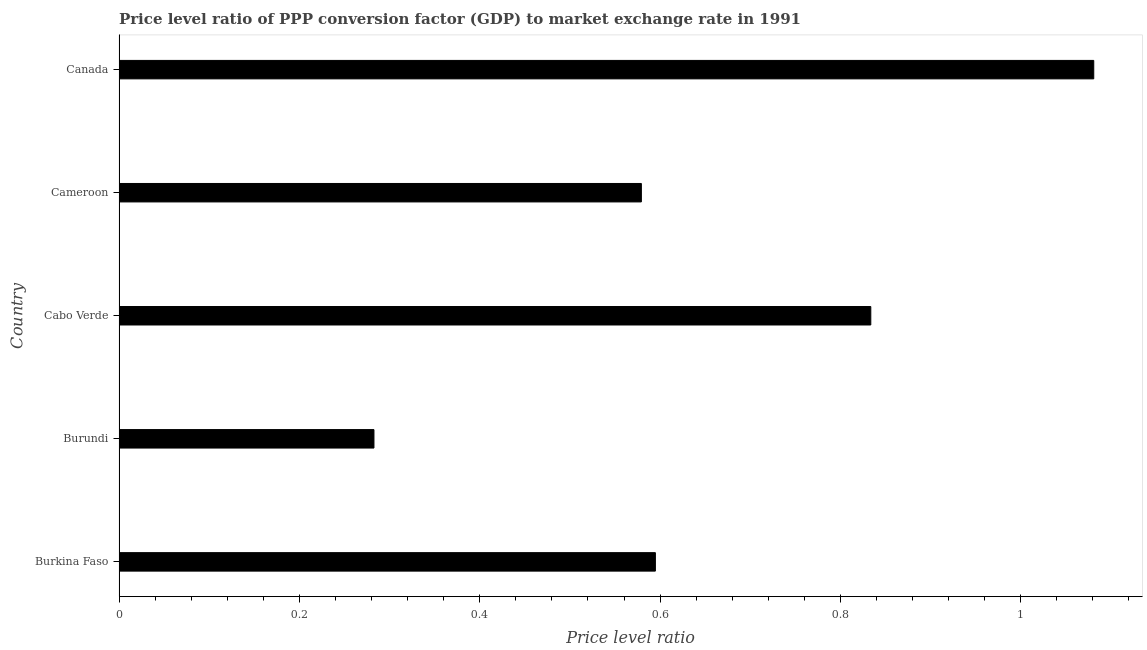Does the graph contain any zero values?
Offer a terse response. No. What is the title of the graph?
Offer a terse response. Price level ratio of PPP conversion factor (GDP) to market exchange rate in 1991. What is the label or title of the X-axis?
Provide a short and direct response. Price level ratio. What is the label or title of the Y-axis?
Ensure brevity in your answer.  Country. What is the price level ratio in Cameroon?
Give a very brief answer. 0.58. Across all countries, what is the maximum price level ratio?
Provide a short and direct response. 1.08. Across all countries, what is the minimum price level ratio?
Provide a succinct answer. 0.28. In which country was the price level ratio minimum?
Your answer should be very brief. Burundi. What is the sum of the price level ratio?
Make the answer very short. 3.37. What is the difference between the price level ratio in Burkina Faso and Burundi?
Your response must be concise. 0.31. What is the average price level ratio per country?
Your answer should be compact. 0.67. What is the median price level ratio?
Give a very brief answer. 0.59. What is the ratio of the price level ratio in Burkina Faso to that in Canada?
Your response must be concise. 0.55. Is the price level ratio in Cabo Verde less than that in Canada?
Provide a succinct answer. Yes. Is the difference between the price level ratio in Burkina Faso and Cameroon greater than the difference between any two countries?
Make the answer very short. No. What is the difference between the highest and the second highest price level ratio?
Offer a very short reply. 0.25. What is the difference between the highest and the lowest price level ratio?
Provide a short and direct response. 0.8. In how many countries, is the price level ratio greater than the average price level ratio taken over all countries?
Keep it short and to the point. 2. Are the values on the major ticks of X-axis written in scientific E-notation?
Keep it short and to the point. No. What is the Price level ratio of Burkina Faso?
Your response must be concise. 0.59. What is the Price level ratio of Burundi?
Provide a succinct answer. 0.28. What is the Price level ratio in Cabo Verde?
Keep it short and to the point. 0.83. What is the Price level ratio of Cameroon?
Ensure brevity in your answer.  0.58. What is the Price level ratio of Canada?
Keep it short and to the point. 1.08. What is the difference between the Price level ratio in Burkina Faso and Burundi?
Offer a terse response. 0.31. What is the difference between the Price level ratio in Burkina Faso and Cabo Verde?
Provide a succinct answer. -0.24. What is the difference between the Price level ratio in Burkina Faso and Cameroon?
Ensure brevity in your answer.  0.02. What is the difference between the Price level ratio in Burkina Faso and Canada?
Give a very brief answer. -0.49. What is the difference between the Price level ratio in Burundi and Cabo Verde?
Give a very brief answer. -0.55. What is the difference between the Price level ratio in Burundi and Cameroon?
Keep it short and to the point. -0.3. What is the difference between the Price level ratio in Burundi and Canada?
Your answer should be compact. -0.8. What is the difference between the Price level ratio in Cabo Verde and Cameroon?
Offer a terse response. 0.25. What is the difference between the Price level ratio in Cabo Verde and Canada?
Keep it short and to the point. -0.25. What is the difference between the Price level ratio in Cameroon and Canada?
Your answer should be compact. -0.5. What is the ratio of the Price level ratio in Burkina Faso to that in Burundi?
Ensure brevity in your answer.  2.1. What is the ratio of the Price level ratio in Burkina Faso to that in Cabo Verde?
Provide a short and direct response. 0.71. What is the ratio of the Price level ratio in Burkina Faso to that in Canada?
Keep it short and to the point. 0.55. What is the ratio of the Price level ratio in Burundi to that in Cabo Verde?
Keep it short and to the point. 0.34. What is the ratio of the Price level ratio in Burundi to that in Cameroon?
Provide a succinct answer. 0.49. What is the ratio of the Price level ratio in Burundi to that in Canada?
Your answer should be compact. 0.26. What is the ratio of the Price level ratio in Cabo Verde to that in Cameroon?
Your response must be concise. 1.44. What is the ratio of the Price level ratio in Cabo Verde to that in Canada?
Your response must be concise. 0.77. What is the ratio of the Price level ratio in Cameroon to that in Canada?
Your response must be concise. 0.54. 